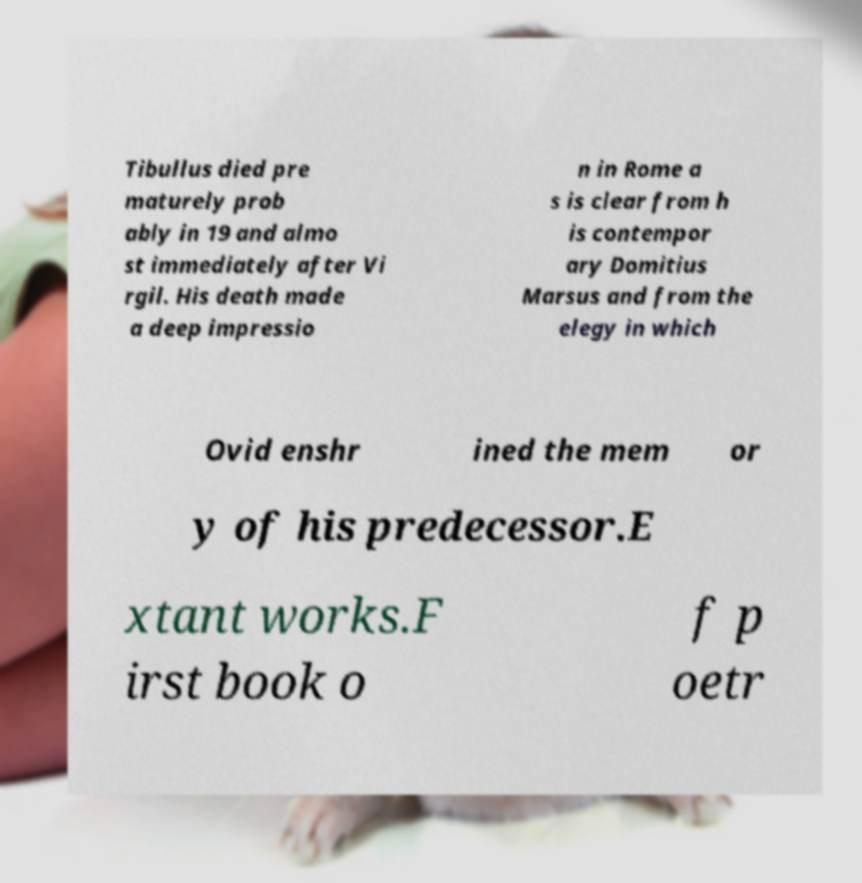Could you assist in decoding the text presented in this image and type it out clearly? Tibullus died pre maturely prob ably in 19 and almo st immediately after Vi rgil. His death made a deep impressio n in Rome a s is clear from h is contempor ary Domitius Marsus and from the elegy in which Ovid enshr ined the mem or y of his predecessor.E xtant works.F irst book o f p oetr 